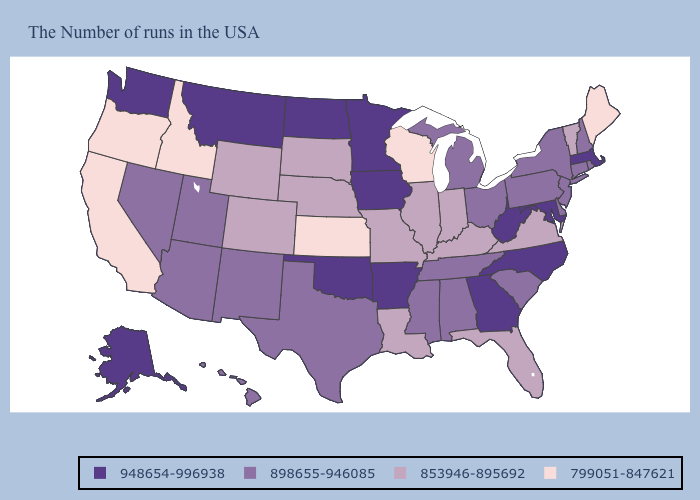Does the map have missing data?
Short answer required. No. Among the states that border Florida , does Georgia have the lowest value?
Keep it brief. No. Name the states that have a value in the range 799051-847621?
Write a very short answer. Maine, Wisconsin, Kansas, Idaho, California, Oregon. What is the highest value in the MidWest ?
Short answer required. 948654-996938. What is the lowest value in the MidWest?
Short answer required. 799051-847621. What is the value of Arizona?
Give a very brief answer. 898655-946085. Does the first symbol in the legend represent the smallest category?
Concise answer only. No. Does Nevada have a lower value than Minnesota?
Quick response, please. Yes. What is the value of Arizona?
Short answer required. 898655-946085. Does Louisiana have the lowest value in the USA?
Write a very short answer. No. Does Missouri have a higher value than California?
Give a very brief answer. Yes. Among the states that border Iowa , does Minnesota have the highest value?
Give a very brief answer. Yes. Which states hav the highest value in the MidWest?
Quick response, please. Minnesota, Iowa, North Dakota. Which states have the lowest value in the Northeast?
Concise answer only. Maine. Among the states that border Kentucky , which have the highest value?
Short answer required. West Virginia. 